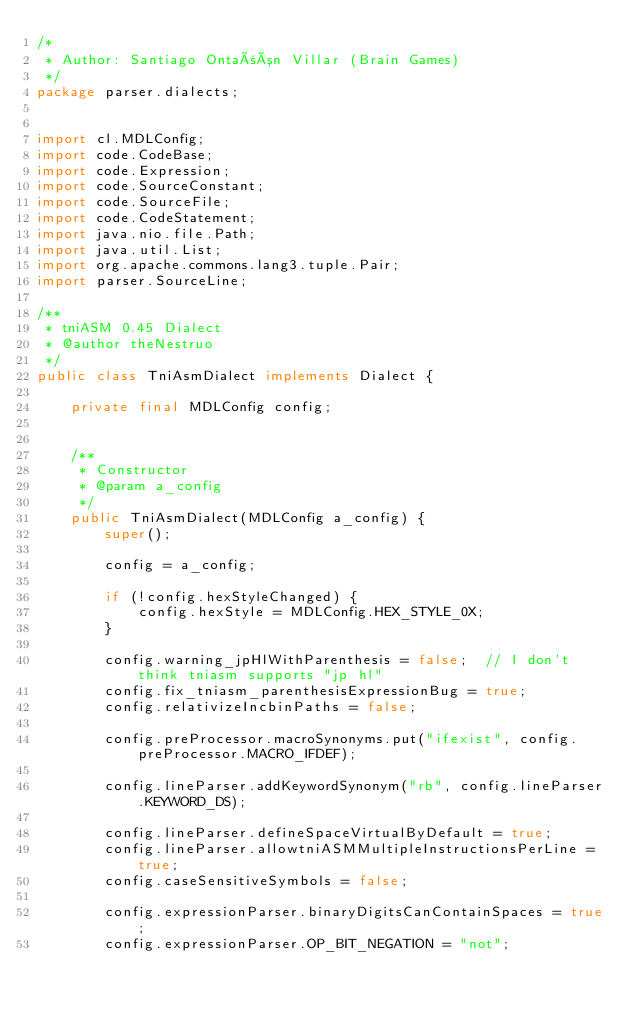Convert code to text. <code><loc_0><loc_0><loc_500><loc_500><_Java_>/*
 * Author: Santiago Ontañón Villar (Brain Games)
 */
package parser.dialects;


import cl.MDLConfig;
import code.CodeBase;
import code.Expression;
import code.SourceConstant;
import code.SourceFile;
import code.CodeStatement;
import java.nio.file.Path;
import java.util.List;
import org.apache.commons.lang3.tuple.Pair;
import parser.SourceLine;

/**
 * tniASM 0.45 Dialect
 * @author theNestruo
 */
public class TniAsmDialect implements Dialect {

    private final MDLConfig config;


    /**
     * Constructor
     * @param a_config
     */
    public TniAsmDialect(MDLConfig a_config) {
        super();

        config = a_config;
        
        if (!config.hexStyleChanged) {
            config.hexStyle = MDLConfig.HEX_STYLE_0X;
        }
        
        config.warning_jpHlWithParenthesis = false;  // I don't think tniasm supports "jp hl"
        config.fix_tniasm_parenthesisExpressionBug = true;
        config.relativizeIncbinPaths = false;

        config.preProcessor.macroSynonyms.put("ifexist", config.preProcessor.MACRO_IFDEF);
        
        config.lineParser.addKeywordSynonym("rb", config.lineParser.KEYWORD_DS);
        
        config.lineParser.defineSpaceVirtualByDefault = true;
        config.lineParser.allowtniASMMultipleInstructionsPerLine = true;
        config.caseSensitiveSymbols = false;
        
        config.expressionParser.binaryDigitsCanContainSpaces = true;
        config.expressionParser.OP_BIT_NEGATION = "not";</code> 